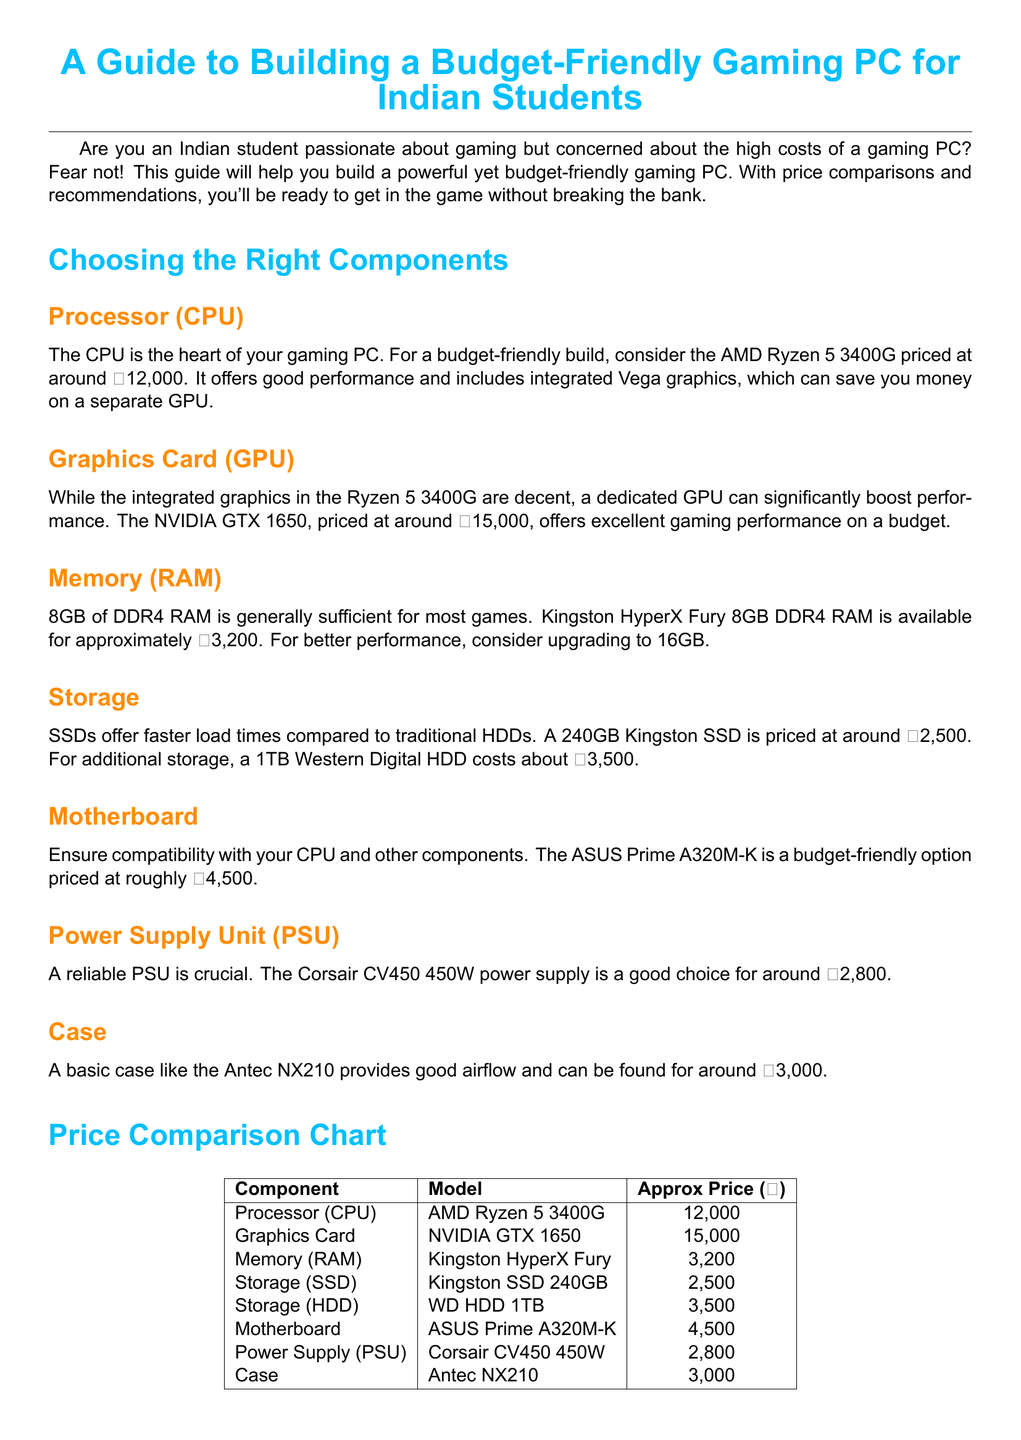What is the price of the AMD Ryzen 5 3400G? The price of the AMD Ryzen 5 3400G is specifically mentioned in the document as ₹12,000.
Answer: ₹12,000 What type of RAM is recommended for gaming? The recommended type of RAM is explicitly noted in the document as DDR4 RAM.
Answer: DDR4 RAM How much does the NVIDIA GTX 1650 cost? The cost of the NVIDIA GTX 1650 is listed in the document as ₹15,000.
Answer: ₹15,000 Which motherboard is suggested for a budget-friendly build? The suggested motherboard for a budget-friendly build in the document is the ASUS Prime A320M-K.
Answer: ASUS Prime A320M-K What is the total price of the basic case? The price of the basic case mentioned in the document is ₹3,000.
Answer: ₹3,000 Which power supply is recommended in the guide? The recommended power supply in the guide is the Corsair CV450 450W.
Answer: Corsair CV450 450W How many GB of RAM is sufficient for most games according to the document? The document states that 8GB of RAM is generally sufficient for most games.
Answer: 8GB What component can significantly boost gaming performance? The component that can significantly boost gaming performance, as stated in the document, is the dedicated GPU.
Answer: Dedicated GPU What is the approximate price of the Kingston SSD 240GB? The approximate price of the Kingston SSD 240GB is explicitly detailed in the document as ₹2,500.
Answer: ₹2,500 